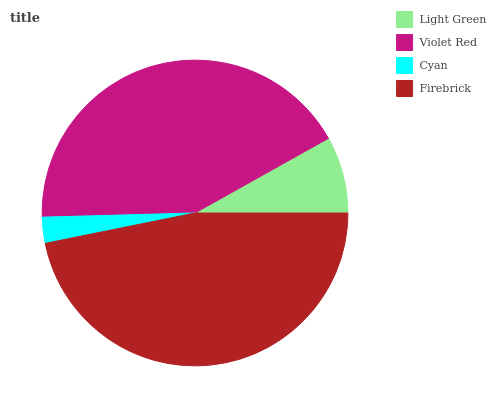Is Cyan the minimum?
Answer yes or no. Yes. Is Firebrick the maximum?
Answer yes or no. Yes. Is Violet Red the minimum?
Answer yes or no. No. Is Violet Red the maximum?
Answer yes or no. No. Is Violet Red greater than Light Green?
Answer yes or no. Yes. Is Light Green less than Violet Red?
Answer yes or no. Yes. Is Light Green greater than Violet Red?
Answer yes or no. No. Is Violet Red less than Light Green?
Answer yes or no. No. Is Violet Red the high median?
Answer yes or no. Yes. Is Light Green the low median?
Answer yes or no. Yes. Is Firebrick the high median?
Answer yes or no. No. Is Firebrick the low median?
Answer yes or no. No. 